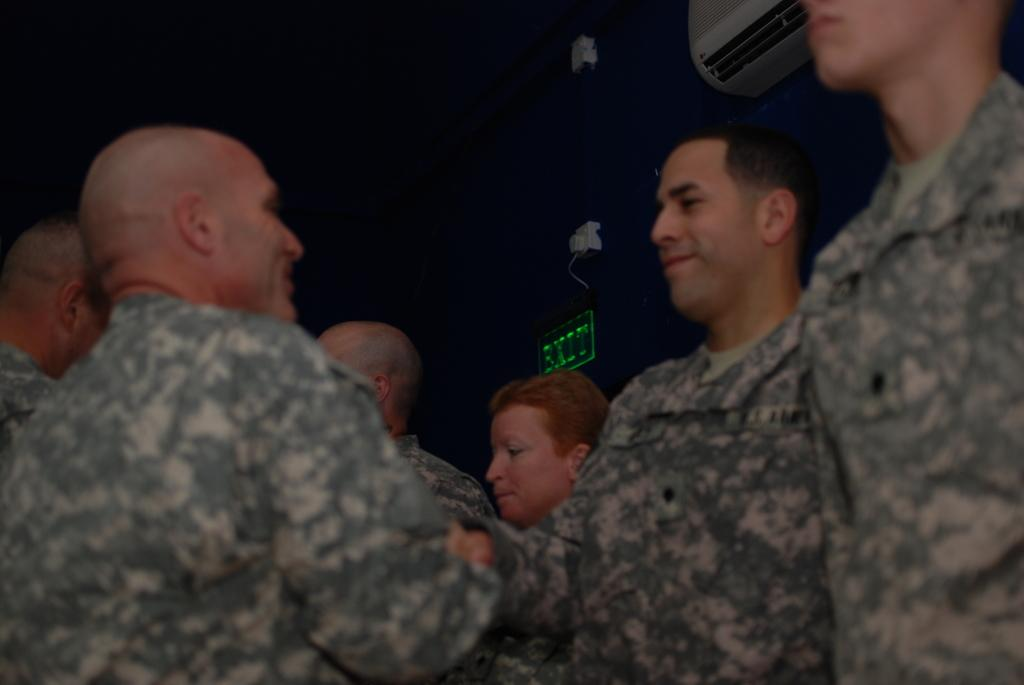How many people are in the image? There are persons in the image, but the exact number is not specified. What can be seen in the background of the image? There is a board and an AC on the wall in the background of the image. What type of cow can be seen laughing in the image? There is no cow present in the image, and therefore no such activity can be observed. 